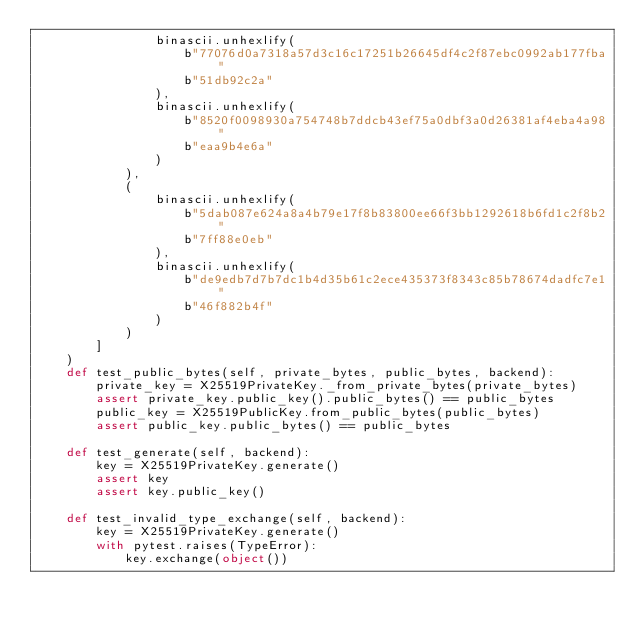Convert code to text. <code><loc_0><loc_0><loc_500><loc_500><_Python_>                binascii.unhexlify(
                    b"77076d0a7318a57d3c16c17251b26645df4c2f87ebc0992ab177fba"
                    b"51db92c2a"
                ),
                binascii.unhexlify(
                    b"8520f0098930a754748b7ddcb43ef75a0dbf3a0d26381af4eba4a98"
                    b"eaa9b4e6a"
                )
            ),
            (
                binascii.unhexlify(
                    b"5dab087e624a8a4b79e17f8b83800ee66f3bb1292618b6fd1c2f8b2"
                    b"7ff88e0eb"
                ),
                binascii.unhexlify(
                    b"de9edb7d7b7dc1b4d35b61c2ece435373f8343c85b78674dadfc7e1"
                    b"46f882b4f"
                )
            )
        ]
    )
    def test_public_bytes(self, private_bytes, public_bytes, backend):
        private_key = X25519PrivateKey._from_private_bytes(private_bytes)
        assert private_key.public_key().public_bytes() == public_bytes
        public_key = X25519PublicKey.from_public_bytes(public_bytes)
        assert public_key.public_bytes() == public_bytes

    def test_generate(self, backend):
        key = X25519PrivateKey.generate()
        assert key
        assert key.public_key()

    def test_invalid_type_exchange(self, backend):
        key = X25519PrivateKey.generate()
        with pytest.raises(TypeError):
            key.exchange(object())
</code> 